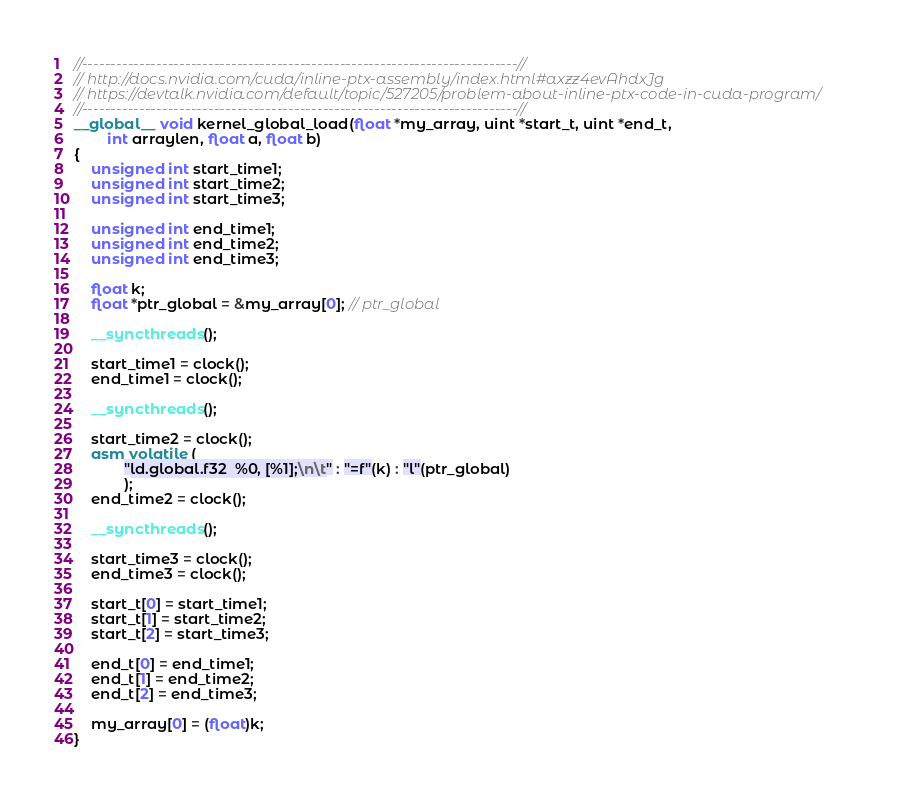Convert code to text. <code><loc_0><loc_0><loc_500><loc_500><_Cuda_>//----------------------------------------------------------------------------//
// http://docs.nvidia.com/cuda/inline-ptx-assembly/index.html#axzz4evAhdxJg
// https://devtalk.nvidia.com/default/topic/527205/problem-about-inline-ptx-code-in-cuda-program/
//----------------------------------------------------------------------------//
__global__ void kernel_global_load(float *my_array, uint *start_t, uint *end_t, 
		int arraylen, float a, float b)
{
	unsigned int start_time1;                                                   
	unsigned int start_time2;                                                   
	unsigned int start_time3;                                                   

	unsigned int end_time1;                                                     
	unsigned int end_time2;                                                     
	unsigned int end_time3;                                                     

	float k;
	float *ptr_global = &my_array[0]; // ptr_global

	__syncthreads();                                                            

	start_time1 = clock();                                                      
	end_time1 = clock();                                                        

	__syncthreads();                                                            

	start_time2 = clock();                                                      
	asm volatile (                                                              
			"ld.global.f32  %0, [%1];\n\t" : "=f"(k) : "l"(ptr_global)
			);                                                                  
	end_time2 = clock();                                                        

	__syncthreads();                                                            

	start_time3 = clock();                                                      
	end_time3 = clock();                                                        

	start_t[0] = start_time1;                                                   
	start_t[1] = start_time2;                                                   
	start_t[2] = start_time3;                                                   

	end_t[0] = end_time1;                                                       
	end_t[1] = end_time2;                                                       
	end_t[2] = end_time3;                                                       

	my_array[0] = (float)k;
}
</code> 